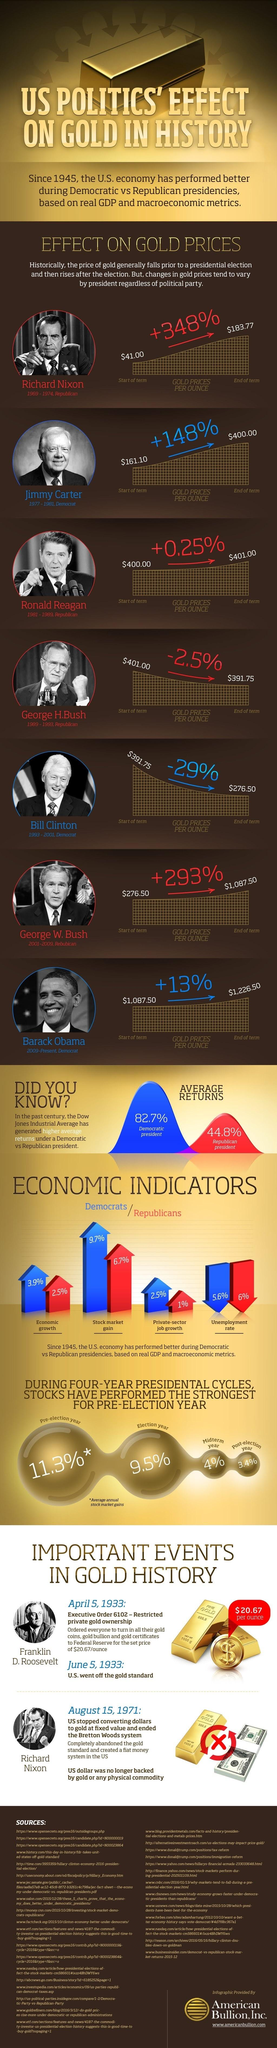Identify some key points in this picture. The average annual stock market gain percentage in an election year is 9.5%. During Democratic presidencies since 1945, the percentage of economic growth was 3.9%. The unemployment rate during Republican presidencies since 1945 has decreased by 6%. Since 1945, the stock market has gained an average of 9.7% during Democratic presidencies. Gold prices per ounce increased by 13% during the presidency of Barack Obama. 